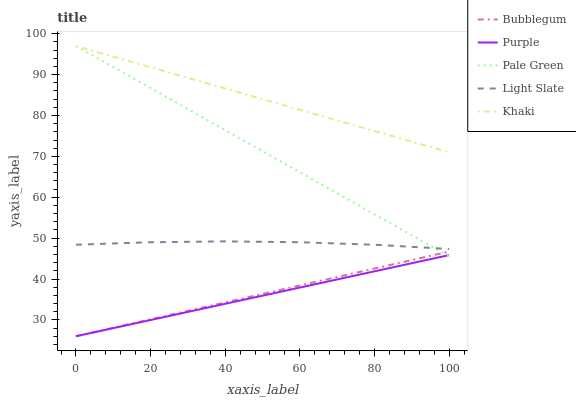Does Purple have the minimum area under the curve?
Answer yes or no. Yes. Does Khaki have the maximum area under the curve?
Answer yes or no. Yes. Does Light Slate have the minimum area under the curve?
Answer yes or no. No. Does Light Slate have the maximum area under the curve?
Answer yes or no. No. Is Bubblegum the smoothest?
Answer yes or no. Yes. Is Light Slate the roughest?
Answer yes or no. Yes. Is Pale Green the smoothest?
Answer yes or no. No. Is Pale Green the roughest?
Answer yes or no. No. Does Purple have the lowest value?
Answer yes or no. Yes. Does Light Slate have the lowest value?
Answer yes or no. No. Does Khaki have the highest value?
Answer yes or no. Yes. Does Light Slate have the highest value?
Answer yes or no. No. Is Purple less than Light Slate?
Answer yes or no. Yes. Is Khaki greater than Light Slate?
Answer yes or no. Yes. Does Khaki intersect Pale Green?
Answer yes or no. Yes. Is Khaki less than Pale Green?
Answer yes or no. No. Is Khaki greater than Pale Green?
Answer yes or no. No. Does Purple intersect Light Slate?
Answer yes or no. No. 